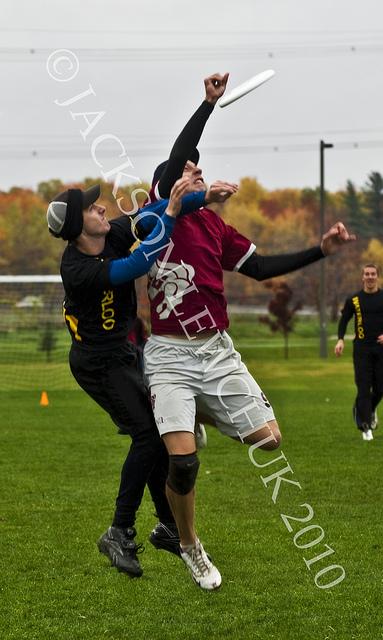What color is the frisbee?
Quick response, please. White. What sport is being played?
Give a very brief answer. Frisbee. How many feet are in the air?
Keep it brief. 4. What game is being played?
Give a very brief answer. Frisbee. What is floating in the air?
Short answer required. Frisbee. What are the players playing?
Answer briefly. Frisbee. Is the man in the back topless?
Write a very short answer. No. How many people are on the ground?
Answer briefly. 1. What sport is it?
Write a very short answer. Frisbee. Which person initially caught the frisbee?
Answer briefly. Front one. Are they playing a game?
Concise answer only. Yes. What are they playing?
Short answer required. Frisbee. How many frisbees is the man holding?
Answer briefly. 1. Which player has the knee injury?
Keep it brief. Front. What number is on the black shirt?
Be succinct. 5. What color are their uniforms?
Be succinct. Black. 